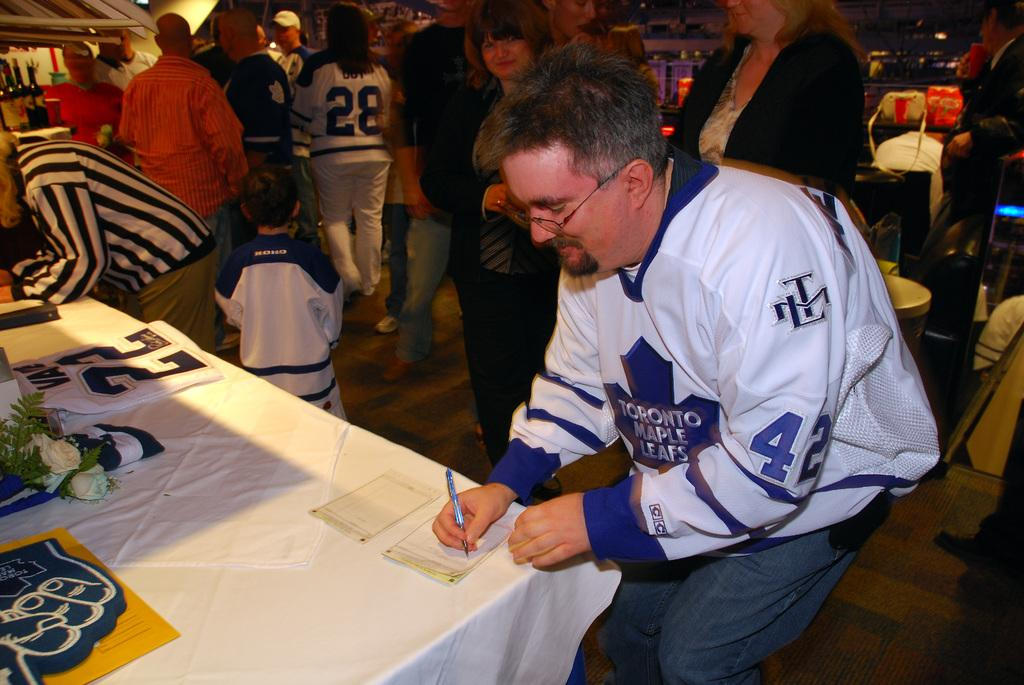<image>
Relay a brief, clear account of the picture shown. A man, wearing a Toronto Maple Leafs jersey, writes on paper. 